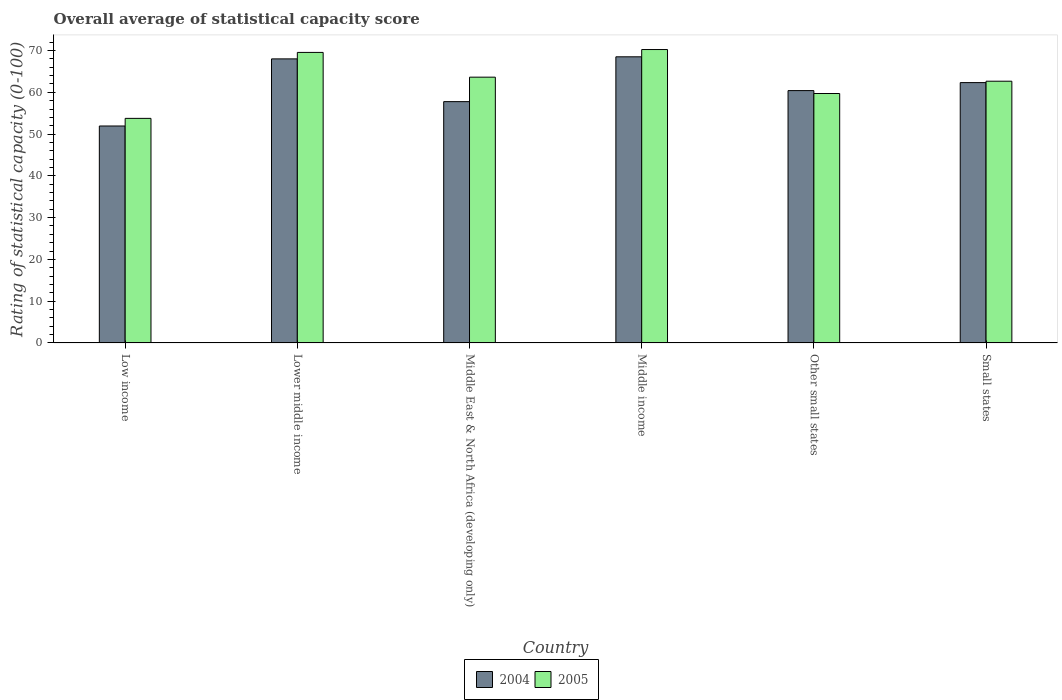How many groups of bars are there?
Keep it short and to the point. 6. Are the number of bars per tick equal to the number of legend labels?
Give a very brief answer. Yes. What is the label of the 3rd group of bars from the left?
Your answer should be very brief. Middle East & North Africa (developing only). In how many cases, is the number of bars for a given country not equal to the number of legend labels?
Offer a terse response. 0. What is the rating of statistical capacity in 2005 in Middle income?
Keep it short and to the point. 70.25. Across all countries, what is the maximum rating of statistical capacity in 2005?
Your answer should be very brief. 70.25. Across all countries, what is the minimum rating of statistical capacity in 2005?
Provide a succinct answer. 53.77. In which country was the rating of statistical capacity in 2005 maximum?
Your response must be concise. Middle income. What is the total rating of statistical capacity in 2004 in the graph?
Provide a succinct answer. 368.99. What is the difference between the rating of statistical capacity in 2004 in Low income and that in Middle income?
Offer a terse response. -16.56. What is the difference between the rating of statistical capacity in 2005 in Other small states and the rating of statistical capacity in 2004 in Low income?
Make the answer very short. 7.78. What is the average rating of statistical capacity in 2005 per country?
Provide a succinct answer. 63.27. What is the difference between the rating of statistical capacity of/in 2004 and rating of statistical capacity of/in 2005 in Small states?
Ensure brevity in your answer.  -0.33. In how many countries, is the rating of statistical capacity in 2005 greater than 32?
Ensure brevity in your answer.  6. What is the ratio of the rating of statistical capacity in 2004 in Low income to that in Middle East & North Africa (developing only)?
Provide a succinct answer. 0.9. Is the rating of statistical capacity in 2005 in Lower middle income less than that in Middle income?
Your answer should be compact. Yes. Is the difference between the rating of statistical capacity in 2004 in Lower middle income and Middle East & North Africa (developing only) greater than the difference between the rating of statistical capacity in 2005 in Lower middle income and Middle East & North Africa (developing only)?
Offer a very short reply. Yes. What is the difference between the highest and the second highest rating of statistical capacity in 2004?
Offer a very short reply. 6.18. What is the difference between the highest and the lowest rating of statistical capacity in 2004?
Offer a very short reply. 16.56. In how many countries, is the rating of statistical capacity in 2004 greater than the average rating of statistical capacity in 2004 taken over all countries?
Your answer should be very brief. 3. Is the sum of the rating of statistical capacity in 2004 in Middle East & North Africa (developing only) and Other small states greater than the maximum rating of statistical capacity in 2005 across all countries?
Your response must be concise. Yes. What does the 1st bar from the left in Middle income represents?
Provide a succinct answer. 2004. How many bars are there?
Offer a very short reply. 12. Are all the bars in the graph horizontal?
Give a very brief answer. No. How many countries are there in the graph?
Ensure brevity in your answer.  6. What is the difference between two consecutive major ticks on the Y-axis?
Give a very brief answer. 10. Does the graph contain grids?
Give a very brief answer. No. How many legend labels are there?
Your answer should be compact. 2. How are the legend labels stacked?
Keep it short and to the point. Horizontal. What is the title of the graph?
Your answer should be compact. Overall average of statistical capacity score. Does "1988" appear as one of the legend labels in the graph?
Provide a short and direct response. No. What is the label or title of the Y-axis?
Keep it short and to the point. Rating of statistical capacity (0-100). What is the Rating of statistical capacity (0-100) in 2004 in Low income?
Your answer should be very brief. 51.94. What is the Rating of statistical capacity (0-100) in 2005 in Low income?
Ensure brevity in your answer.  53.77. What is the Rating of statistical capacity (0-100) of 2004 in Lower middle income?
Ensure brevity in your answer.  68.01. What is the Rating of statistical capacity (0-100) in 2005 in Lower middle income?
Make the answer very short. 69.56. What is the Rating of statistical capacity (0-100) of 2004 in Middle East & North Africa (developing only)?
Your response must be concise. 57.78. What is the Rating of statistical capacity (0-100) in 2005 in Middle East & North Africa (developing only)?
Your response must be concise. 63.64. What is the Rating of statistical capacity (0-100) of 2004 in Middle income?
Your answer should be compact. 68.51. What is the Rating of statistical capacity (0-100) of 2005 in Middle income?
Your answer should be compact. 70.25. What is the Rating of statistical capacity (0-100) in 2004 in Other small states?
Make the answer very short. 60.42. What is the Rating of statistical capacity (0-100) of 2005 in Other small states?
Ensure brevity in your answer.  59.72. What is the Rating of statistical capacity (0-100) of 2004 in Small states?
Offer a very short reply. 62.33. What is the Rating of statistical capacity (0-100) in 2005 in Small states?
Offer a terse response. 62.67. Across all countries, what is the maximum Rating of statistical capacity (0-100) in 2004?
Your answer should be compact. 68.51. Across all countries, what is the maximum Rating of statistical capacity (0-100) in 2005?
Ensure brevity in your answer.  70.25. Across all countries, what is the minimum Rating of statistical capacity (0-100) in 2004?
Your answer should be compact. 51.94. Across all countries, what is the minimum Rating of statistical capacity (0-100) in 2005?
Offer a terse response. 53.77. What is the total Rating of statistical capacity (0-100) of 2004 in the graph?
Keep it short and to the point. 368.99. What is the total Rating of statistical capacity (0-100) of 2005 in the graph?
Your answer should be very brief. 379.61. What is the difference between the Rating of statistical capacity (0-100) in 2004 in Low income and that in Lower middle income?
Offer a terse response. -16.07. What is the difference between the Rating of statistical capacity (0-100) of 2005 in Low income and that in Lower middle income?
Ensure brevity in your answer.  -15.79. What is the difference between the Rating of statistical capacity (0-100) of 2004 in Low income and that in Middle East & North Africa (developing only)?
Your response must be concise. -5.83. What is the difference between the Rating of statistical capacity (0-100) in 2005 in Low income and that in Middle East & North Africa (developing only)?
Give a very brief answer. -9.87. What is the difference between the Rating of statistical capacity (0-100) of 2004 in Low income and that in Middle income?
Keep it short and to the point. -16.56. What is the difference between the Rating of statistical capacity (0-100) of 2005 in Low income and that in Middle income?
Your response must be concise. -16.48. What is the difference between the Rating of statistical capacity (0-100) in 2004 in Low income and that in Other small states?
Your answer should be very brief. -8.47. What is the difference between the Rating of statistical capacity (0-100) of 2005 in Low income and that in Other small states?
Give a very brief answer. -5.95. What is the difference between the Rating of statistical capacity (0-100) of 2004 in Low income and that in Small states?
Your answer should be compact. -10.39. What is the difference between the Rating of statistical capacity (0-100) in 2005 in Low income and that in Small states?
Provide a succinct answer. -8.9. What is the difference between the Rating of statistical capacity (0-100) of 2004 in Lower middle income and that in Middle East & North Africa (developing only)?
Your response must be concise. 10.23. What is the difference between the Rating of statistical capacity (0-100) of 2005 in Lower middle income and that in Middle East & North Africa (developing only)?
Your answer should be compact. 5.92. What is the difference between the Rating of statistical capacity (0-100) in 2004 in Lower middle income and that in Middle income?
Your answer should be compact. -0.5. What is the difference between the Rating of statistical capacity (0-100) in 2005 in Lower middle income and that in Middle income?
Give a very brief answer. -0.69. What is the difference between the Rating of statistical capacity (0-100) in 2004 in Lower middle income and that in Other small states?
Offer a very short reply. 7.59. What is the difference between the Rating of statistical capacity (0-100) in 2005 in Lower middle income and that in Other small states?
Your answer should be very brief. 9.84. What is the difference between the Rating of statistical capacity (0-100) in 2004 in Lower middle income and that in Small states?
Your answer should be compact. 5.68. What is the difference between the Rating of statistical capacity (0-100) of 2005 in Lower middle income and that in Small states?
Give a very brief answer. 6.89. What is the difference between the Rating of statistical capacity (0-100) in 2004 in Middle East & North Africa (developing only) and that in Middle income?
Provide a succinct answer. -10.73. What is the difference between the Rating of statistical capacity (0-100) in 2005 in Middle East & North Africa (developing only) and that in Middle income?
Your answer should be compact. -6.61. What is the difference between the Rating of statistical capacity (0-100) in 2004 in Middle East & North Africa (developing only) and that in Other small states?
Your response must be concise. -2.64. What is the difference between the Rating of statistical capacity (0-100) of 2005 in Middle East & North Africa (developing only) and that in Other small states?
Give a very brief answer. 3.91. What is the difference between the Rating of statistical capacity (0-100) in 2004 in Middle East & North Africa (developing only) and that in Small states?
Ensure brevity in your answer.  -4.56. What is the difference between the Rating of statistical capacity (0-100) of 2005 in Middle East & North Africa (developing only) and that in Small states?
Keep it short and to the point. 0.97. What is the difference between the Rating of statistical capacity (0-100) of 2004 in Middle income and that in Other small states?
Make the answer very short. 8.09. What is the difference between the Rating of statistical capacity (0-100) in 2005 in Middle income and that in Other small states?
Provide a short and direct response. 10.53. What is the difference between the Rating of statistical capacity (0-100) of 2004 in Middle income and that in Small states?
Provide a short and direct response. 6.18. What is the difference between the Rating of statistical capacity (0-100) of 2005 in Middle income and that in Small states?
Your response must be concise. 7.58. What is the difference between the Rating of statistical capacity (0-100) in 2004 in Other small states and that in Small states?
Keep it short and to the point. -1.92. What is the difference between the Rating of statistical capacity (0-100) in 2005 in Other small states and that in Small states?
Offer a terse response. -2.94. What is the difference between the Rating of statistical capacity (0-100) of 2004 in Low income and the Rating of statistical capacity (0-100) of 2005 in Lower middle income?
Keep it short and to the point. -17.62. What is the difference between the Rating of statistical capacity (0-100) in 2004 in Low income and the Rating of statistical capacity (0-100) in 2005 in Middle East & North Africa (developing only)?
Your answer should be compact. -11.69. What is the difference between the Rating of statistical capacity (0-100) in 2004 in Low income and the Rating of statistical capacity (0-100) in 2005 in Middle income?
Your response must be concise. -18.3. What is the difference between the Rating of statistical capacity (0-100) of 2004 in Low income and the Rating of statistical capacity (0-100) of 2005 in Other small states?
Your answer should be very brief. -7.78. What is the difference between the Rating of statistical capacity (0-100) in 2004 in Low income and the Rating of statistical capacity (0-100) in 2005 in Small states?
Provide a short and direct response. -10.72. What is the difference between the Rating of statistical capacity (0-100) in 2004 in Lower middle income and the Rating of statistical capacity (0-100) in 2005 in Middle East & North Africa (developing only)?
Your response must be concise. 4.38. What is the difference between the Rating of statistical capacity (0-100) of 2004 in Lower middle income and the Rating of statistical capacity (0-100) of 2005 in Middle income?
Offer a terse response. -2.24. What is the difference between the Rating of statistical capacity (0-100) of 2004 in Lower middle income and the Rating of statistical capacity (0-100) of 2005 in Other small states?
Your answer should be compact. 8.29. What is the difference between the Rating of statistical capacity (0-100) in 2004 in Lower middle income and the Rating of statistical capacity (0-100) in 2005 in Small states?
Offer a terse response. 5.34. What is the difference between the Rating of statistical capacity (0-100) in 2004 in Middle East & North Africa (developing only) and the Rating of statistical capacity (0-100) in 2005 in Middle income?
Your answer should be compact. -12.47. What is the difference between the Rating of statistical capacity (0-100) in 2004 in Middle East & North Africa (developing only) and the Rating of statistical capacity (0-100) in 2005 in Other small states?
Your response must be concise. -1.94. What is the difference between the Rating of statistical capacity (0-100) of 2004 in Middle East & North Africa (developing only) and the Rating of statistical capacity (0-100) of 2005 in Small states?
Offer a very short reply. -4.89. What is the difference between the Rating of statistical capacity (0-100) in 2004 in Middle income and the Rating of statistical capacity (0-100) in 2005 in Other small states?
Your answer should be compact. 8.79. What is the difference between the Rating of statistical capacity (0-100) in 2004 in Middle income and the Rating of statistical capacity (0-100) in 2005 in Small states?
Keep it short and to the point. 5.84. What is the difference between the Rating of statistical capacity (0-100) in 2004 in Other small states and the Rating of statistical capacity (0-100) in 2005 in Small states?
Your answer should be compact. -2.25. What is the average Rating of statistical capacity (0-100) of 2004 per country?
Provide a succinct answer. 61.5. What is the average Rating of statistical capacity (0-100) in 2005 per country?
Provide a short and direct response. 63.27. What is the difference between the Rating of statistical capacity (0-100) of 2004 and Rating of statistical capacity (0-100) of 2005 in Low income?
Provide a short and direct response. -1.83. What is the difference between the Rating of statistical capacity (0-100) of 2004 and Rating of statistical capacity (0-100) of 2005 in Lower middle income?
Ensure brevity in your answer.  -1.55. What is the difference between the Rating of statistical capacity (0-100) in 2004 and Rating of statistical capacity (0-100) in 2005 in Middle East & North Africa (developing only)?
Your response must be concise. -5.86. What is the difference between the Rating of statistical capacity (0-100) of 2004 and Rating of statistical capacity (0-100) of 2005 in Middle income?
Your answer should be very brief. -1.74. What is the difference between the Rating of statistical capacity (0-100) of 2004 and Rating of statistical capacity (0-100) of 2005 in Other small states?
Offer a terse response. 0.69. What is the ratio of the Rating of statistical capacity (0-100) of 2004 in Low income to that in Lower middle income?
Provide a short and direct response. 0.76. What is the ratio of the Rating of statistical capacity (0-100) of 2005 in Low income to that in Lower middle income?
Offer a terse response. 0.77. What is the ratio of the Rating of statistical capacity (0-100) in 2004 in Low income to that in Middle East & North Africa (developing only)?
Keep it short and to the point. 0.9. What is the ratio of the Rating of statistical capacity (0-100) of 2005 in Low income to that in Middle East & North Africa (developing only)?
Offer a terse response. 0.84. What is the ratio of the Rating of statistical capacity (0-100) in 2004 in Low income to that in Middle income?
Provide a short and direct response. 0.76. What is the ratio of the Rating of statistical capacity (0-100) in 2005 in Low income to that in Middle income?
Offer a very short reply. 0.77. What is the ratio of the Rating of statistical capacity (0-100) of 2004 in Low income to that in Other small states?
Make the answer very short. 0.86. What is the ratio of the Rating of statistical capacity (0-100) of 2005 in Low income to that in Other small states?
Ensure brevity in your answer.  0.9. What is the ratio of the Rating of statistical capacity (0-100) in 2005 in Low income to that in Small states?
Offer a terse response. 0.86. What is the ratio of the Rating of statistical capacity (0-100) in 2004 in Lower middle income to that in Middle East & North Africa (developing only)?
Offer a very short reply. 1.18. What is the ratio of the Rating of statistical capacity (0-100) of 2005 in Lower middle income to that in Middle East & North Africa (developing only)?
Ensure brevity in your answer.  1.09. What is the ratio of the Rating of statistical capacity (0-100) of 2004 in Lower middle income to that in Middle income?
Offer a terse response. 0.99. What is the ratio of the Rating of statistical capacity (0-100) in 2005 in Lower middle income to that in Middle income?
Your answer should be compact. 0.99. What is the ratio of the Rating of statistical capacity (0-100) in 2004 in Lower middle income to that in Other small states?
Provide a succinct answer. 1.13. What is the ratio of the Rating of statistical capacity (0-100) of 2005 in Lower middle income to that in Other small states?
Offer a terse response. 1.16. What is the ratio of the Rating of statistical capacity (0-100) of 2004 in Lower middle income to that in Small states?
Your answer should be compact. 1.09. What is the ratio of the Rating of statistical capacity (0-100) of 2005 in Lower middle income to that in Small states?
Provide a succinct answer. 1.11. What is the ratio of the Rating of statistical capacity (0-100) in 2004 in Middle East & North Africa (developing only) to that in Middle income?
Ensure brevity in your answer.  0.84. What is the ratio of the Rating of statistical capacity (0-100) of 2005 in Middle East & North Africa (developing only) to that in Middle income?
Offer a very short reply. 0.91. What is the ratio of the Rating of statistical capacity (0-100) of 2004 in Middle East & North Africa (developing only) to that in Other small states?
Ensure brevity in your answer.  0.96. What is the ratio of the Rating of statistical capacity (0-100) of 2005 in Middle East & North Africa (developing only) to that in Other small states?
Your answer should be compact. 1.07. What is the ratio of the Rating of statistical capacity (0-100) of 2004 in Middle East & North Africa (developing only) to that in Small states?
Provide a succinct answer. 0.93. What is the ratio of the Rating of statistical capacity (0-100) in 2005 in Middle East & North Africa (developing only) to that in Small states?
Provide a succinct answer. 1.02. What is the ratio of the Rating of statistical capacity (0-100) in 2004 in Middle income to that in Other small states?
Provide a succinct answer. 1.13. What is the ratio of the Rating of statistical capacity (0-100) in 2005 in Middle income to that in Other small states?
Make the answer very short. 1.18. What is the ratio of the Rating of statistical capacity (0-100) in 2004 in Middle income to that in Small states?
Provide a short and direct response. 1.1. What is the ratio of the Rating of statistical capacity (0-100) in 2005 in Middle income to that in Small states?
Provide a short and direct response. 1.12. What is the ratio of the Rating of statistical capacity (0-100) of 2004 in Other small states to that in Small states?
Keep it short and to the point. 0.97. What is the ratio of the Rating of statistical capacity (0-100) of 2005 in Other small states to that in Small states?
Provide a short and direct response. 0.95. What is the difference between the highest and the second highest Rating of statistical capacity (0-100) of 2004?
Ensure brevity in your answer.  0.5. What is the difference between the highest and the second highest Rating of statistical capacity (0-100) in 2005?
Offer a terse response. 0.69. What is the difference between the highest and the lowest Rating of statistical capacity (0-100) in 2004?
Your answer should be very brief. 16.56. What is the difference between the highest and the lowest Rating of statistical capacity (0-100) in 2005?
Your answer should be compact. 16.48. 